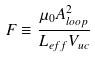<formula> <loc_0><loc_0><loc_500><loc_500>F \equiv \frac { \mu _ { 0 } A _ { l o o p } ^ { 2 } } { L _ { e f f } V _ { u c } }</formula> 